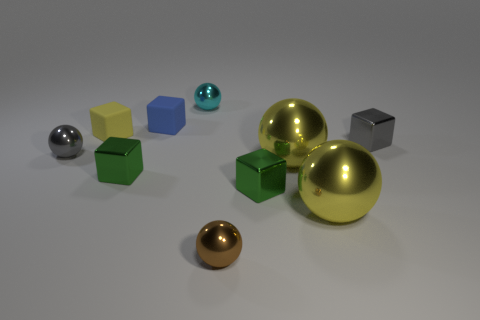Subtract all tiny cyan metallic spheres. How many spheres are left? 4 Subtract 4 spheres. How many spheres are left? 1 Subtract all gray blocks. How many blocks are left? 4 Add 4 tiny gray balls. How many tiny gray balls exist? 5 Subtract 0 yellow cylinders. How many objects are left? 10 Subtract all cyan blocks. Subtract all cyan cylinders. How many blocks are left? 5 Subtract all red spheres. How many yellow blocks are left? 1 Subtract all small brown things. Subtract all green cubes. How many objects are left? 7 Add 5 tiny brown metallic spheres. How many tiny brown metallic spheres are left? 6 